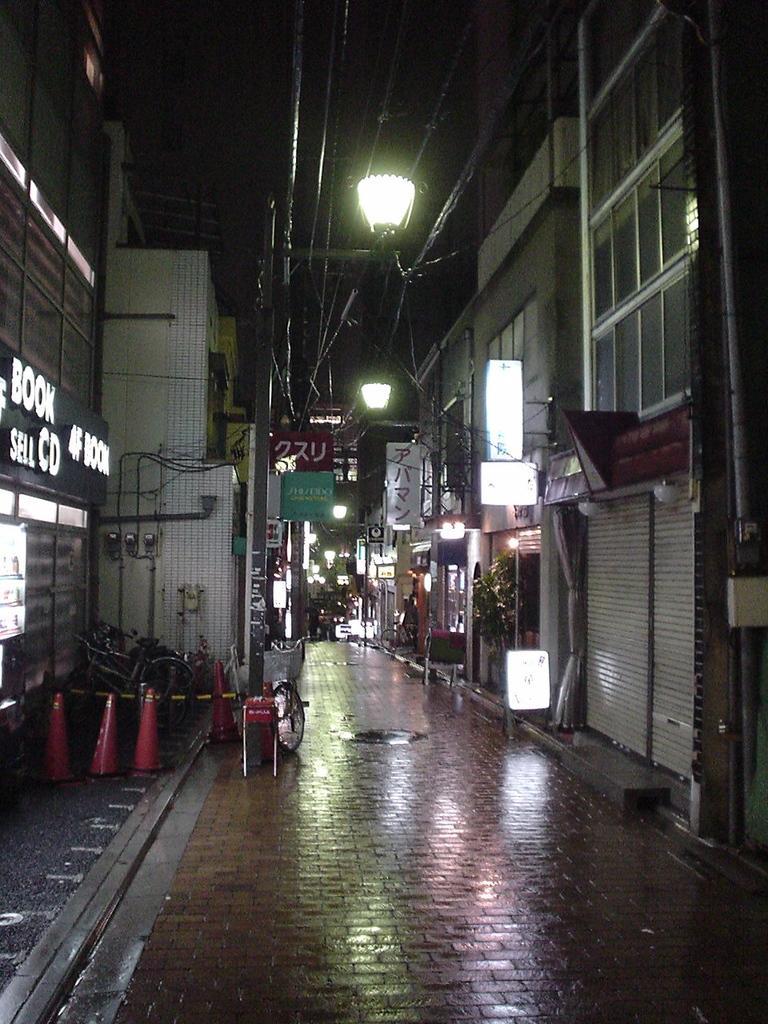Can you describe this image briefly? In this image we can see street. There are many buildings. Also we can see shutters. There are lights. On the left side we can see traffic cones. Also there are names on the buildings. 